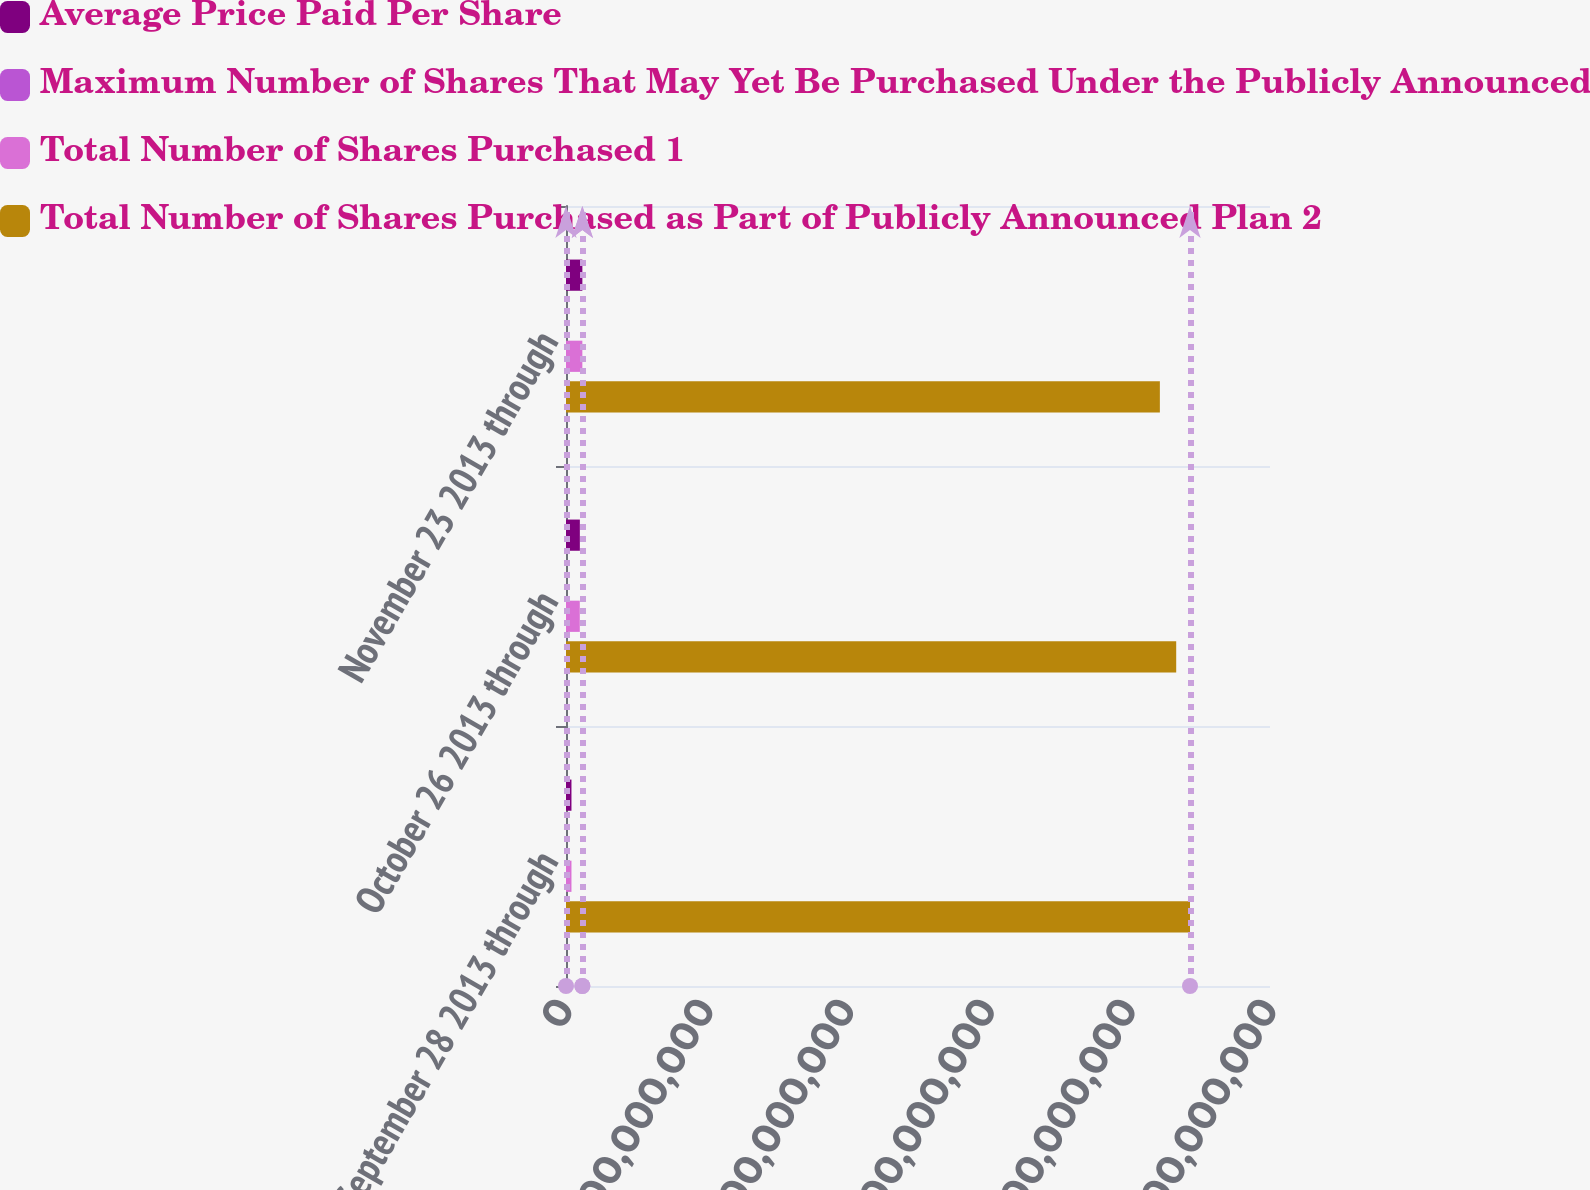<chart> <loc_0><loc_0><loc_500><loc_500><stacked_bar_chart><ecel><fcel>September 28 2013 through<fcel>October 26 2013 through<fcel>November 23 2013 through<nl><fcel>Average Price Paid Per Share<fcel>3.88179e+06<fcel>9.83799e+06<fcel>1.16288e+07<nl><fcel>Maximum Number of Shares That May Yet Be Purchased Under the Publicly Announced Plan<fcel>38.54<fcel>39.93<fcel>40.14<nl><fcel>Total Number of Shares Purchased 1<fcel>3.88e+06<fcel>9.7955e+06<fcel>1.16093e+07<nl><fcel>Total Number of Shares Purchased as Part of Publicly Announced Plan 2<fcel>4.43184e+08<fcel>4.33388e+08<fcel>4.21779e+08<nl></chart> 